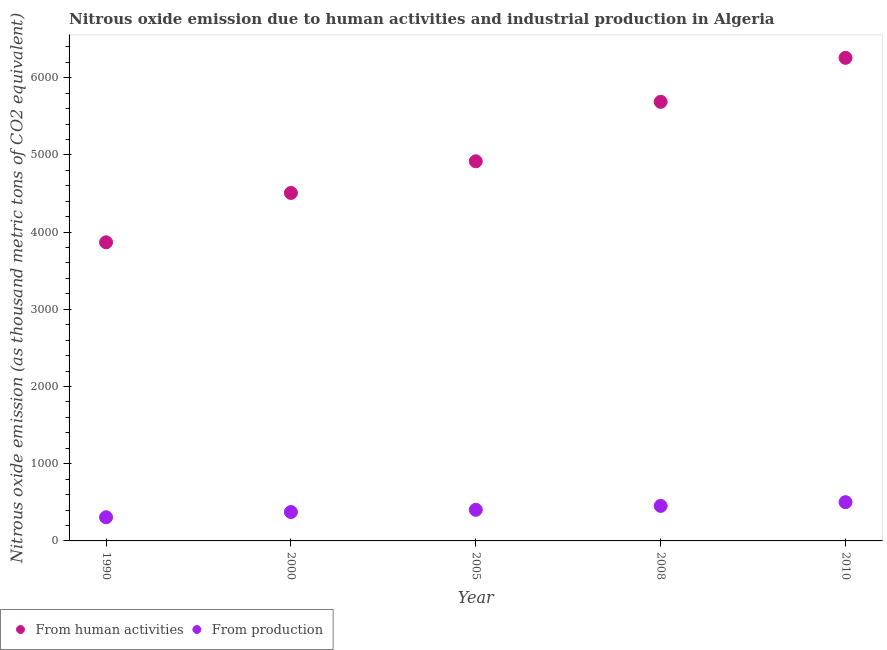How many different coloured dotlines are there?
Provide a short and direct response. 2. What is the amount of emissions from human activities in 2005?
Keep it short and to the point. 4917. Across all years, what is the maximum amount of emissions from human activities?
Ensure brevity in your answer.  6256.9. Across all years, what is the minimum amount of emissions generated from industries?
Give a very brief answer. 306.3. What is the total amount of emissions from human activities in the graph?
Your answer should be compact. 2.52e+04. What is the difference between the amount of emissions generated from industries in 1990 and that in 2005?
Ensure brevity in your answer.  -97. What is the difference between the amount of emissions from human activities in 2010 and the amount of emissions generated from industries in 2005?
Give a very brief answer. 5853.6. What is the average amount of emissions generated from industries per year?
Your answer should be compact. 407.88. In the year 2010, what is the difference between the amount of emissions generated from industries and amount of emissions from human activities?
Ensure brevity in your answer.  -5755. In how many years, is the amount of emissions from human activities greater than 3800 thousand metric tons?
Provide a short and direct response. 5. What is the ratio of the amount of emissions from human activities in 2008 to that in 2010?
Provide a short and direct response. 0.91. Is the amount of emissions generated from industries in 2000 less than that in 2010?
Your response must be concise. Yes. Is the difference between the amount of emissions from human activities in 2000 and 2008 greater than the difference between the amount of emissions generated from industries in 2000 and 2008?
Make the answer very short. No. What is the difference between the highest and the second highest amount of emissions from human activities?
Ensure brevity in your answer.  569.7. What is the difference between the highest and the lowest amount of emissions generated from industries?
Your answer should be very brief. 195.6. Is the sum of the amount of emissions generated from industries in 2000 and 2008 greater than the maximum amount of emissions from human activities across all years?
Offer a very short reply. No. Does the amount of emissions from human activities monotonically increase over the years?
Make the answer very short. Yes. Is the amount of emissions generated from industries strictly greater than the amount of emissions from human activities over the years?
Offer a very short reply. No. Is the amount of emissions from human activities strictly less than the amount of emissions generated from industries over the years?
Your answer should be very brief. No. How many years are there in the graph?
Offer a very short reply. 5. Are the values on the major ticks of Y-axis written in scientific E-notation?
Offer a terse response. No. Does the graph contain any zero values?
Your response must be concise. No. Does the graph contain grids?
Offer a very short reply. No. How many legend labels are there?
Offer a very short reply. 2. What is the title of the graph?
Make the answer very short. Nitrous oxide emission due to human activities and industrial production in Algeria. Does "Exports" appear as one of the legend labels in the graph?
Your answer should be very brief. No. What is the label or title of the Y-axis?
Your answer should be very brief. Nitrous oxide emission (as thousand metric tons of CO2 equivalent). What is the Nitrous oxide emission (as thousand metric tons of CO2 equivalent) of From human activities in 1990?
Keep it short and to the point. 3867.6. What is the Nitrous oxide emission (as thousand metric tons of CO2 equivalent) in From production in 1990?
Your answer should be very brief. 306.3. What is the Nitrous oxide emission (as thousand metric tons of CO2 equivalent) of From human activities in 2000?
Make the answer very short. 4507.1. What is the Nitrous oxide emission (as thousand metric tons of CO2 equivalent) of From production in 2000?
Your answer should be compact. 374.2. What is the Nitrous oxide emission (as thousand metric tons of CO2 equivalent) of From human activities in 2005?
Provide a succinct answer. 4917. What is the Nitrous oxide emission (as thousand metric tons of CO2 equivalent) in From production in 2005?
Your response must be concise. 403.3. What is the Nitrous oxide emission (as thousand metric tons of CO2 equivalent) of From human activities in 2008?
Keep it short and to the point. 5687.2. What is the Nitrous oxide emission (as thousand metric tons of CO2 equivalent) in From production in 2008?
Your response must be concise. 453.7. What is the Nitrous oxide emission (as thousand metric tons of CO2 equivalent) of From human activities in 2010?
Keep it short and to the point. 6256.9. What is the Nitrous oxide emission (as thousand metric tons of CO2 equivalent) of From production in 2010?
Your answer should be compact. 501.9. Across all years, what is the maximum Nitrous oxide emission (as thousand metric tons of CO2 equivalent) in From human activities?
Keep it short and to the point. 6256.9. Across all years, what is the maximum Nitrous oxide emission (as thousand metric tons of CO2 equivalent) of From production?
Your answer should be very brief. 501.9. Across all years, what is the minimum Nitrous oxide emission (as thousand metric tons of CO2 equivalent) of From human activities?
Your answer should be very brief. 3867.6. Across all years, what is the minimum Nitrous oxide emission (as thousand metric tons of CO2 equivalent) of From production?
Ensure brevity in your answer.  306.3. What is the total Nitrous oxide emission (as thousand metric tons of CO2 equivalent) in From human activities in the graph?
Provide a short and direct response. 2.52e+04. What is the total Nitrous oxide emission (as thousand metric tons of CO2 equivalent) of From production in the graph?
Ensure brevity in your answer.  2039.4. What is the difference between the Nitrous oxide emission (as thousand metric tons of CO2 equivalent) of From human activities in 1990 and that in 2000?
Keep it short and to the point. -639.5. What is the difference between the Nitrous oxide emission (as thousand metric tons of CO2 equivalent) in From production in 1990 and that in 2000?
Ensure brevity in your answer.  -67.9. What is the difference between the Nitrous oxide emission (as thousand metric tons of CO2 equivalent) of From human activities in 1990 and that in 2005?
Ensure brevity in your answer.  -1049.4. What is the difference between the Nitrous oxide emission (as thousand metric tons of CO2 equivalent) of From production in 1990 and that in 2005?
Offer a terse response. -97. What is the difference between the Nitrous oxide emission (as thousand metric tons of CO2 equivalent) in From human activities in 1990 and that in 2008?
Your answer should be very brief. -1819.6. What is the difference between the Nitrous oxide emission (as thousand metric tons of CO2 equivalent) of From production in 1990 and that in 2008?
Provide a short and direct response. -147.4. What is the difference between the Nitrous oxide emission (as thousand metric tons of CO2 equivalent) in From human activities in 1990 and that in 2010?
Your answer should be compact. -2389.3. What is the difference between the Nitrous oxide emission (as thousand metric tons of CO2 equivalent) of From production in 1990 and that in 2010?
Your answer should be compact. -195.6. What is the difference between the Nitrous oxide emission (as thousand metric tons of CO2 equivalent) of From human activities in 2000 and that in 2005?
Offer a very short reply. -409.9. What is the difference between the Nitrous oxide emission (as thousand metric tons of CO2 equivalent) of From production in 2000 and that in 2005?
Offer a very short reply. -29.1. What is the difference between the Nitrous oxide emission (as thousand metric tons of CO2 equivalent) of From human activities in 2000 and that in 2008?
Your answer should be compact. -1180.1. What is the difference between the Nitrous oxide emission (as thousand metric tons of CO2 equivalent) in From production in 2000 and that in 2008?
Give a very brief answer. -79.5. What is the difference between the Nitrous oxide emission (as thousand metric tons of CO2 equivalent) in From human activities in 2000 and that in 2010?
Your response must be concise. -1749.8. What is the difference between the Nitrous oxide emission (as thousand metric tons of CO2 equivalent) in From production in 2000 and that in 2010?
Your answer should be very brief. -127.7. What is the difference between the Nitrous oxide emission (as thousand metric tons of CO2 equivalent) of From human activities in 2005 and that in 2008?
Provide a succinct answer. -770.2. What is the difference between the Nitrous oxide emission (as thousand metric tons of CO2 equivalent) of From production in 2005 and that in 2008?
Provide a short and direct response. -50.4. What is the difference between the Nitrous oxide emission (as thousand metric tons of CO2 equivalent) in From human activities in 2005 and that in 2010?
Your response must be concise. -1339.9. What is the difference between the Nitrous oxide emission (as thousand metric tons of CO2 equivalent) of From production in 2005 and that in 2010?
Make the answer very short. -98.6. What is the difference between the Nitrous oxide emission (as thousand metric tons of CO2 equivalent) in From human activities in 2008 and that in 2010?
Your answer should be very brief. -569.7. What is the difference between the Nitrous oxide emission (as thousand metric tons of CO2 equivalent) in From production in 2008 and that in 2010?
Make the answer very short. -48.2. What is the difference between the Nitrous oxide emission (as thousand metric tons of CO2 equivalent) in From human activities in 1990 and the Nitrous oxide emission (as thousand metric tons of CO2 equivalent) in From production in 2000?
Your answer should be very brief. 3493.4. What is the difference between the Nitrous oxide emission (as thousand metric tons of CO2 equivalent) of From human activities in 1990 and the Nitrous oxide emission (as thousand metric tons of CO2 equivalent) of From production in 2005?
Ensure brevity in your answer.  3464.3. What is the difference between the Nitrous oxide emission (as thousand metric tons of CO2 equivalent) of From human activities in 1990 and the Nitrous oxide emission (as thousand metric tons of CO2 equivalent) of From production in 2008?
Ensure brevity in your answer.  3413.9. What is the difference between the Nitrous oxide emission (as thousand metric tons of CO2 equivalent) of From human activities in 1990 and the Nitrous oxide emission (as thousand metric tons of CO2 equivalent) of From production in 2010?
Keep it short and to the point. 3365.7. What is the difference between the Nitrous oxide emission (as thousand metric tons of CO2 equivalent) in From human activities in 2000 and the Nitrous oxide emission (as thousand metric tons of CO2 equivalent) in From production in 2005?
Keep it short and to the point. 4103.8. What is the difference between the Nitrous oxide emission (as thousand metric tons of CO2 equivalent) in From human activities in 2000 and the Nitrous oxide emission (as thousand metric tons of CO2 equivalent) in From production in 2008?
Keep it short and to the point. 4053.4. What is the difference between the Nitrous oxide emission (as thousand metric tons of CO2 equivalent) in From human activities in 2000 and the Nitrous oxide emission (as thousand metric tons of CO2 equivalent) in From production in 2010?
Your answer should be very brief. 4005.2. What is the difference between the Nitrous oxide emission (as thousand metric tons of CO2 equivalent) in From human activities in 2005 and the Nitrous oxide emission (as thousand metric tons of CO2 equivalent) in From production in 2008?
Your response must be concise. 4463.3. What is the difference between the Nitrous oxide emission (as thousand metric tons of CO2 equivalent) in From human activities in 2005 and the Nitrous oxide emission (as thousand metric tons of CO2 equivalent) in From production in 2010?
Your answer should be very brief. 4415.1. What is the difference between the Nitrous oxide emission (as thousand metric tons of CO2 equivalent) in From human activities in 2008 and the Nitrous oxide emission (as thousand metric tons of CO2 equivalent) in From production in 2010?
Provide a short and direct response. 5185.3. What is the average Nitrous oxide emission (as thousand metric tons of CO2 equivalent) in From human activities per year?
Ensure brevity in your answer.  5047.16. What is the average Nitrous oxide emission (as thousand metric tons of CO2 equivalent) in From production per year?
Your answer should be compact. 407.88. In the year 1990, what is the difference between the Nitrous oxide emission (as thousand metric tons of CO2 equivalent) of From human activities and Nitrous oxide emission (as thousand metric tons of CO2 equivalent) of From production?
Your response must be concise. 3561.3. In the year 2000, what is the difference between the Nitrous oxide emission (as thousand metric tons of CO2 equivalent) in From human activities and Nitrous oxide emission (as thousand metric tons of CO2 equivalent) in From production?
Ensure brevity in your answer.  4132.9. In the year 2005, what is the difference between the Nitrous oxide emission (as thousand metric tons of CO2 equivalent) of From human activities and Nitrous oxide emission (as thousand metric tons of CO2 equivalent) of From production?
Your answer should be very brief. 4513.7. In the year 2008, what is the difference between the Nitrous oxide emission (as thousand metric tons of CO2 equivalent) of From human activities and Nitrous oxide emission (as thousand metric tons of CO2 equivalent) of From production?
Provide a succinct answer. 5233.5. In the year 2010, what is the difference between the Nitrous oxide emission (as thousand metric tons of CO2 equivalent) of From human activities and Nitrous oxide emission (as thousand metric tons of CO2 equivalent) of From production?
Provide a succinct answer. 5755. What is the ratio of the Nitrous oxide emission (as thousand metric tons of CO2 equivalent) of From human activities in 1990 to that in 2000?
Offer a very short reply. 0.86. What is the ratio of the Nitrous oxide emission (as thousand metric tons of CO2 equivalent) in From production in 1990 to that in 2000?
Your response must be concise. 0.82. What is the ratio of the Nitrous oxide emission (as thousand metric tons of CO2 equivalent) of From human activities in 1990 to that in 2005?
Your answer should be very brief. 0.79. What is the ratio of the Nitrous oxide emission (as thousand metric tons of CO2 equivalent) of From production in 1990 to that in 2005?
Your answer should be very brief. 0.76. What is the ratio of the Nitrous oxide emission (as thousand metric tons of CO2 equivalent) of From human activities in 1990 to that in 2008?
Your response must be concise. 0.68. What is the ratio of the Nitrous oxide emission (as thousand metric tons of CO2 equivalent) in From production in 1990 to that in 2008?
Offer a very short reply. 0.68. What is the ratio of the Nitrous oxide emission (as thousand metric tons of CO2 equivalent) of From human activities in 1990 to that in 2010?
Ensure brevity in your answer.  0.62. What is the ratio of the Nitrous oxide emission (as thousand metric tons of CO2 equivalent) of From production in 1990 to that in 2010?
Your answer should be very brief. 0.61. What is the ratio of the Nitrous oxide emission (as thousand metric tons of CO2 equivalent) in From human activities in 2000 to that in 2005?
Keep it short and to the point. 0.92. What is the ratio of the Nitrous oxide emission (as thousand metric tons of CO2 equivalent) in From production in 2000 to that in 2005?
Provide a succinct answer. 0.93. What is the ratio of the Nitrous oxide emission (as thousand metric tons of CO2 equivalent) of From human activities in 2000 to that in 2008?
Give a very brief answer. 0.79. What is the ratio of the Nitrous oxide emission (as thousand metric tons of CO2 equivalent) in From production in 2000 to that in 2008?
Make the answer very short. 0.82. What is the ratio of the Nitrous oxide emission (as thousand metric tons of CO2 equivalent) of From human activities in 2000 to that in 2010?
Make the answer very short. 0.72. What is the ratio of the Nitrous oxide emission (as thousand metric tons of CO2 equivalent) in From production in 2000 to that in 2010?
Offer a terse response. 0.75. What is the ratio of the Nitrous oxide emission (as thousand metric tons of CO2 equivalent) of From human activities in 2005 to that in 2008?
Make the answer very short. 0.86. What is the ratio of the Nitrous oxide emission (as thousand metric tons of CO2 equivalent) of From production in 2005 to that in 2008?
Provide a short and direct response. 0.89. What is the ratio of the Nitrous oxide emission (as thousand metric tons of CO2 equivalent) of From human activities in 2005 to that in 2010?
Make the answer very short. 0.79. What is the ratio of the Nitrous oxide emission (as thousand metric tons of CO2 equivalent) of From production in 2005 to that in 2010?
Your response must be concise. 0.8. What is the ratio of the Nitrous oxide emission (as thousand metric tons of CO2 equivalent) in From human activities in 2008 to that in 2010?
Ensure brevity in your answer.  0.91. What is the ratio of the Nitrous oxide emission (as thousand metric tons of CO2 equivalent) of From production in 2008 to that in 2010?
Provide a succinct answer. 0.9. What is the difference between the highest and the second highest Nitrous oxide emission (as thousand metric tons of CO2 equivalent) in From human activities?
Ensure brevity in your answer.  569.7. What is the difference between the highest and the second highest Nitrous oxide emission (as thousand metric tons of CO2 equivalent) in From production?
Provide a succinct answer. 48.2. What is the difference between the highest and the lowest Nitrous oxide emission (as thousand metric tons of CO2 equivalent) in From human activities?
Offer a very short reply. 2389.3. What is the difference between the highest and the lowest Nitrous oxide emission (as thousand metric tons of CO2 equivalent) of From production?
Make the answer very short. 195.6. 